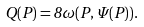<formula> <loc_0><loc_0><loc_500><loc_500>Q ( P ) = 8 \omega ( P , \Psi ( P ) ) .</formula> 